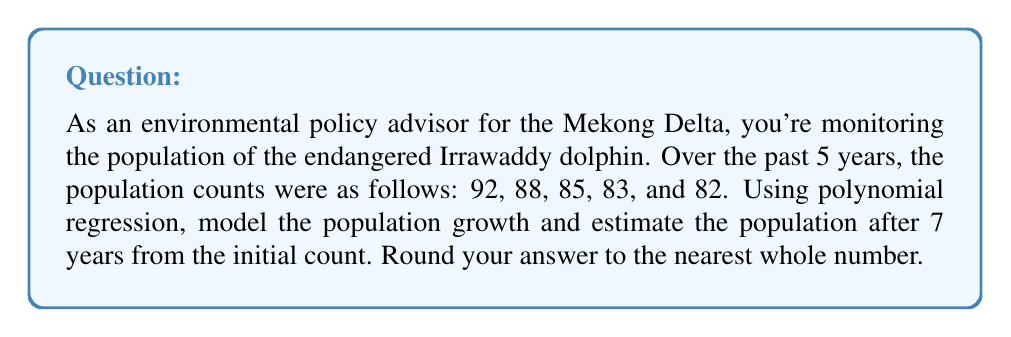Can you answer this question? Let's approach this step-by-step:

1) First, we'll set up our data points. Let x represent the number of years since the initial count, and y represent the population:

   (0, 92), (1, 88), (2, 85), (3, 83), (4, 82)

2) We'll use a second-degree polynomial regression model: $y = ax^2 + bx + c$

3) To find the coefficients a, b, and c, we can use a system of normal equations or a matrix method. For simplicity, let's use a polynomial regression calculator.

4) After inputting the data points, we get the following equation:

   $y = 0.5x^2 - 4.5x + 92$

5) To estimate the population after 7 years, we substitute x = 7 into our equation:

   $y = 0.5(7)^2 - 4.5(7) + 92$
   $= 0.5(49) - 31.5 + 92$
   $= 24.5 - 31.5 + 92$
   $= 85$

6) Rounding to the nearest whole number, we get 85.

This model suggests that the population decline is slowing down and may start to increase again, which could be due to conservation efforts. However, it's important to note that extrapolating beyond the range of observed data should be done cautiously, as many factors can influence population dynamics.
Answer: 85 Irrawaddy dolphins 